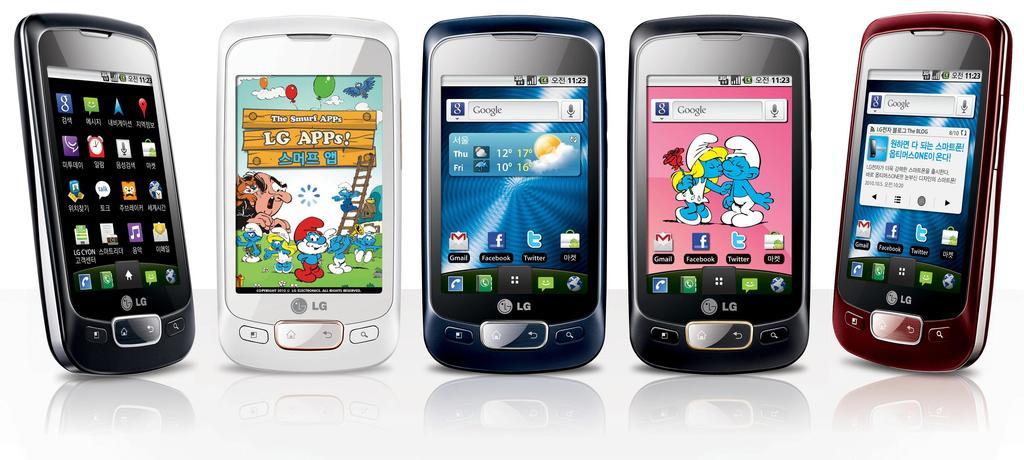What is the brand of phone shonw?
Offer a very short reply. Lg. Which search engine is being used?
Keep it short and to the point. Google. 